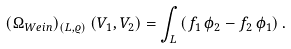<formula> <loc_0><loc_0><loc_500><loc_500>( \Omega _ { W e i n } ) _ { ( L , \varrho ) } \left ( V _ { 1 } , V _ { 2 } \right ) = \int _ { L } \left ( f _ { 1 } \, \phi _ { 2 } - f _ { 2 } \, \phi _ { 1 } \right ) .</formula> 